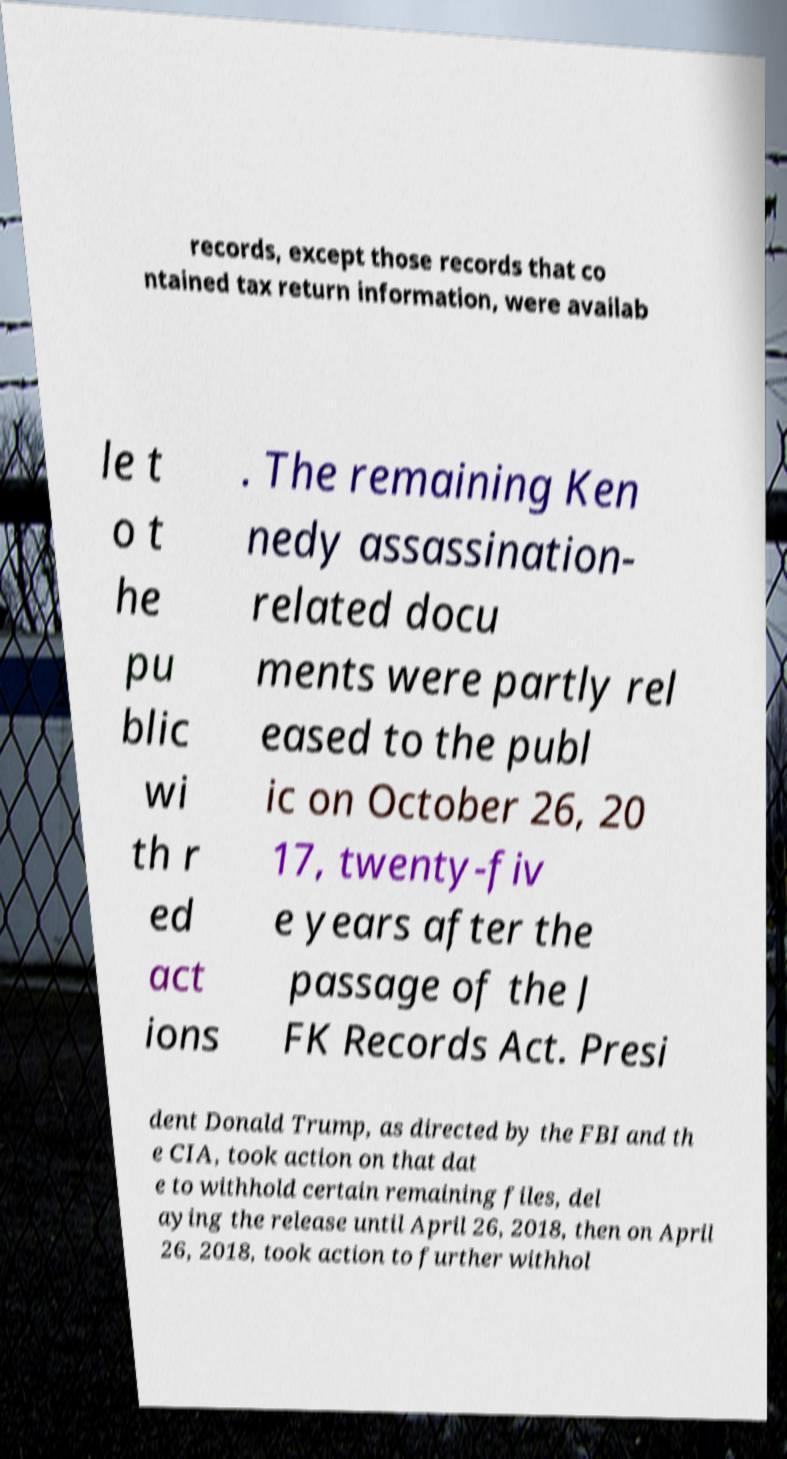There's text embedded in this image that I need extracted. Can you transcribe it verbatim? records, except those records that co ntained tax return information, were availab le t o t he pu blic wi th r ed act ions . The remaining Ken nedy assassination- related docu ments were partly rel eased to the publ ic on October 26, 20 17, twenty-fiv e years after the passage of the J FK Records Act. Presi dent Donald Trump, as directed by the FBI and th e CIA, took action on that dat e to withhold certain remaining files, del aying the release until April 26, 2018, then on April 26, 2018, took action to further withhol 